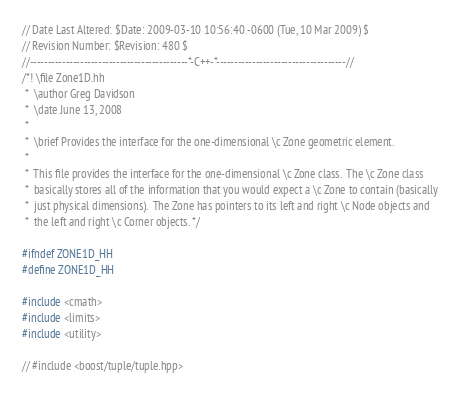<code> <loc_0><loc_0><loc_500><loc_500><_C++_>// Date Last Altered: $Date: 2009-03-10 10:56:40 -0600 (Tue, 10 Mar 2009) $
// Revision Number: $Revision: 480 $
//--------------------------------------------*-C++-*------------------------------------//
/*! \file Zone1D.hh
 *  \author Greg Davidson
 *  \date June 13, 2008
 * 
 *  \brief Provides the interface for the one-dimensional \c Zone geometric element.
 *
 *  This file provides the interface for the one-dimensional \c Zone class.  The \c Zone class
 *  basically stores all of the information that you would expect a \c Zone to contain (basically
 *  just physical dimensions).  The Zone has pointers to its left and right \c Node objects and 
 *  the left and right \c Corner objects. */

#ifndef ZONE1D_HH
#define ZONE1D_HH

#include <cmath>
#include <limits>
#include <utility>

// #include <boost/tuple/tuple.hpp>
</code> 